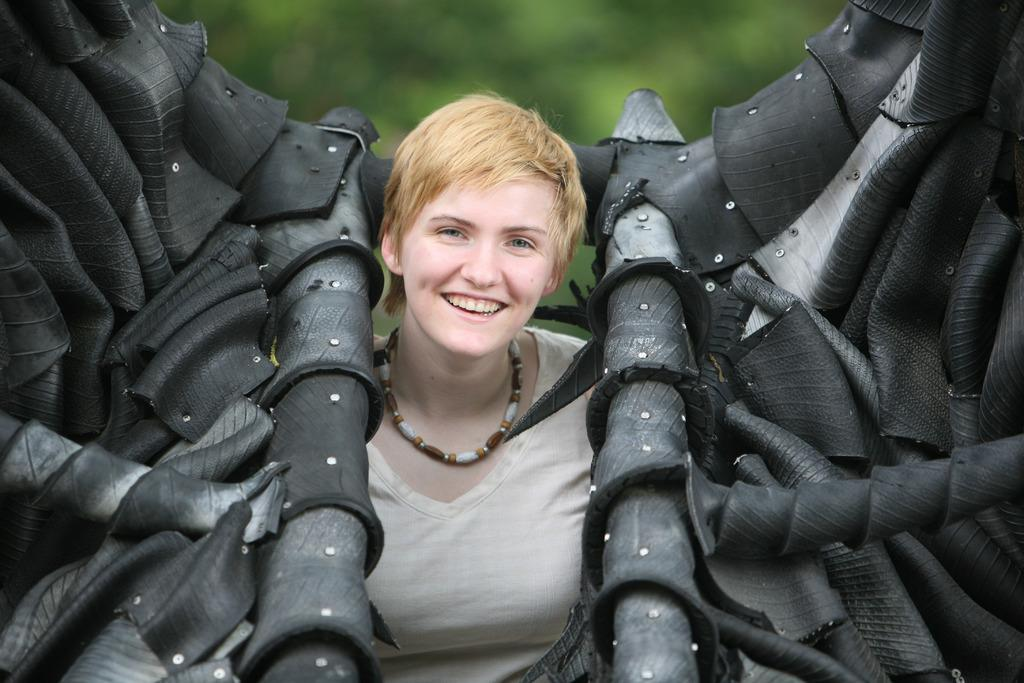Who is present in the image? There is a person in the image. What is the person doing in the image? The person is smiling. What is the person wearing in the image? The person is wearing a white top. What can be seen on both sides of the person? There are black color objects on both sides of the person. What is the color of the background in the image? The background of the image is green. What type of jewel can be seen around the person's neck in the image? There is no jewel visible around the person's neck in the image. How does the person wash their hands in the image? The image does not show the person washing their hands, so it cannot be determined from the image. 